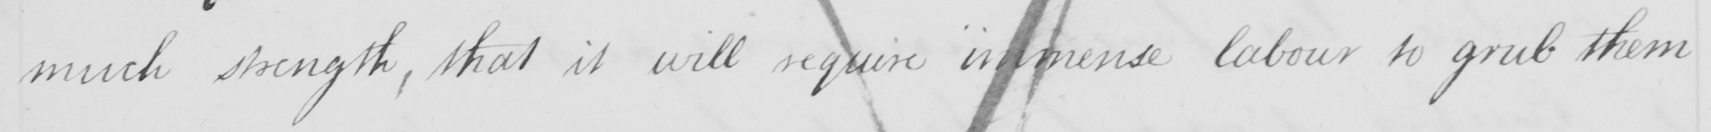Please transcribe the handwritten text in this image. much strength. that it will require immense labour to grab them 